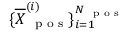<formula> <loc_0><loc_0><loc_500><loc_500>\{ \overline { \boldsymbol X } _ { p o s } ^ { ( i ) } \} _ { i = 1 } ^ { N _ { p o s } }</formula> 